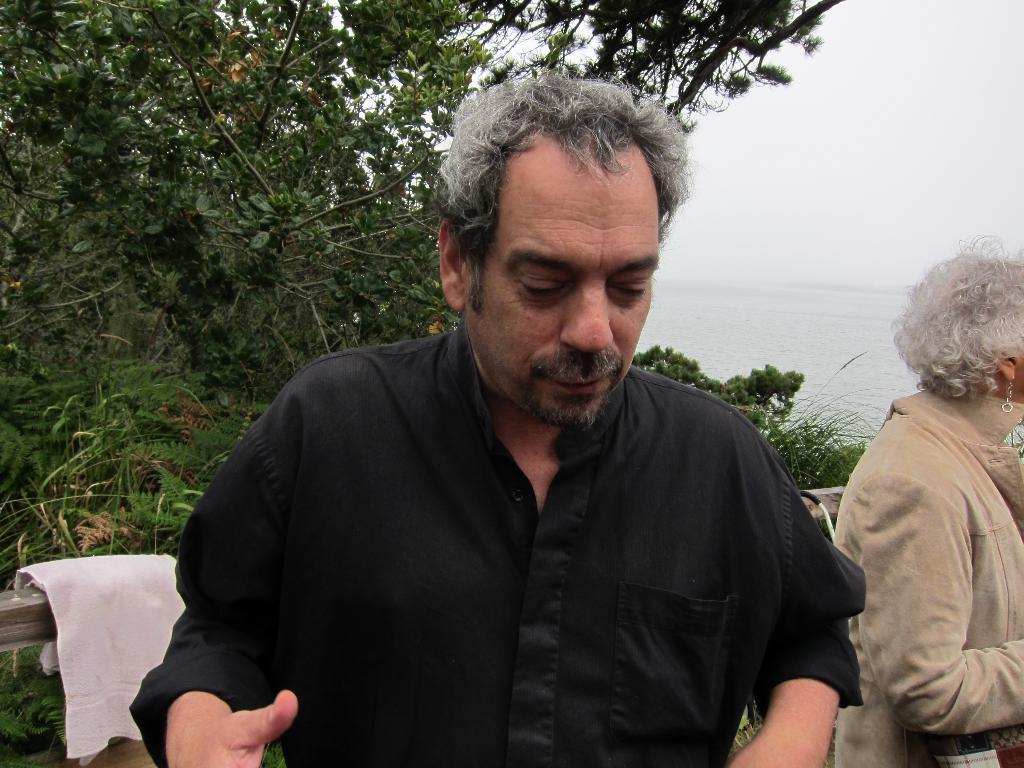Can you describe this image briefly? In this image in the foreground there is one man and one woman, and in the background there is one cloth and some objects, trees and grass and there is a river. At the top there is sky. 